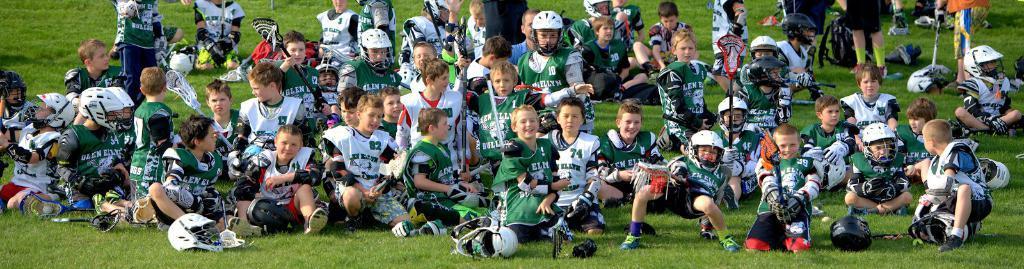How would you summarize this image in a sentence or two? In this image there are a few people sitting in the grass in which some of them are wearing helmets, there are a few people standing on the grass and there are some helmets on the grass. 